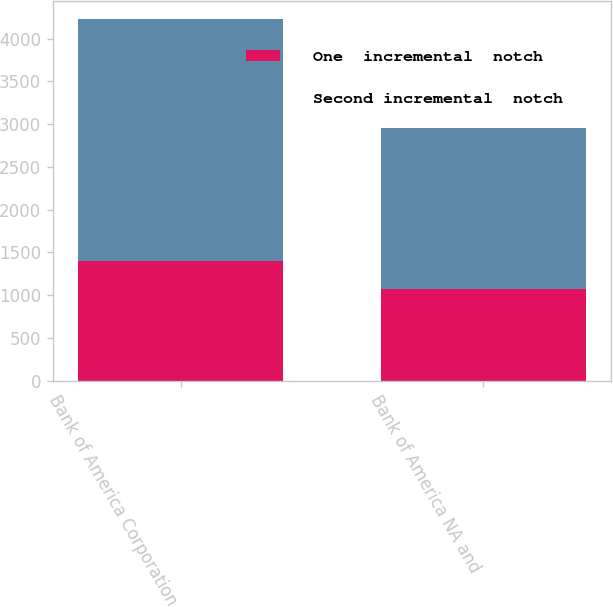Convert chart to OTSL. <chart><loc_0><loc_0><loc_500><loc_500><stacked_bar_chart><ecel><fcel>Bank of America Corporation<fcel>Bank of America NA and<nl><fcel>One  incremental  notch<fcel>1402<fcel>1072<nl><fcel>Second incremental  notch<fcel>2825<fcel>1886<nl></chart> 